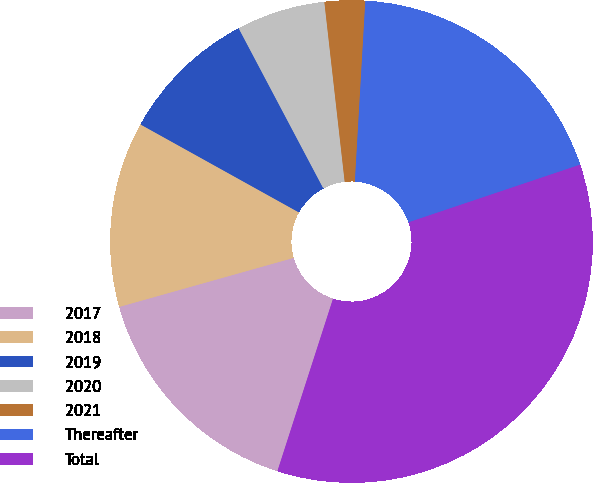Convert chart to OTSL. <chart><loc_0><loc_0><loc_500><loc_500><pie_chart><fcel>2017<fcel>2018<fcel>2019<fcel>2020<fcel>2021<fcel>Thereafter<fcel>Total<nl><fcel>15.67%<fcel>12.43%<fcel>9.19%<fcel>5.95%<fcel>2.71%<fcel>18.92%<fcel>35.12%<nl></chart> 